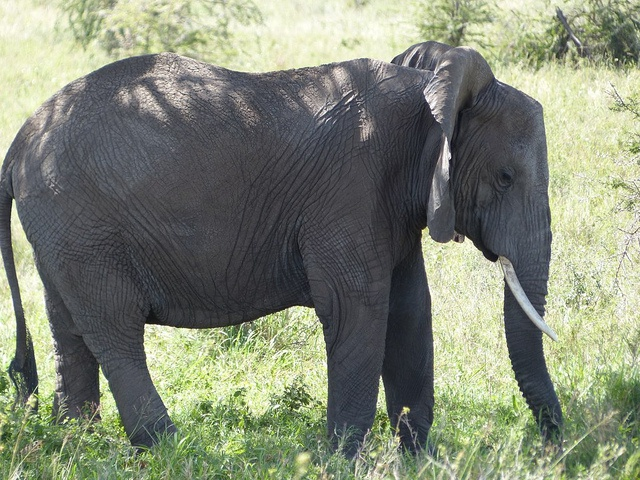Describe the objects in this image and their specific colors. I can see a elephant in beige, gray, black, and darkgray tones in this image. 